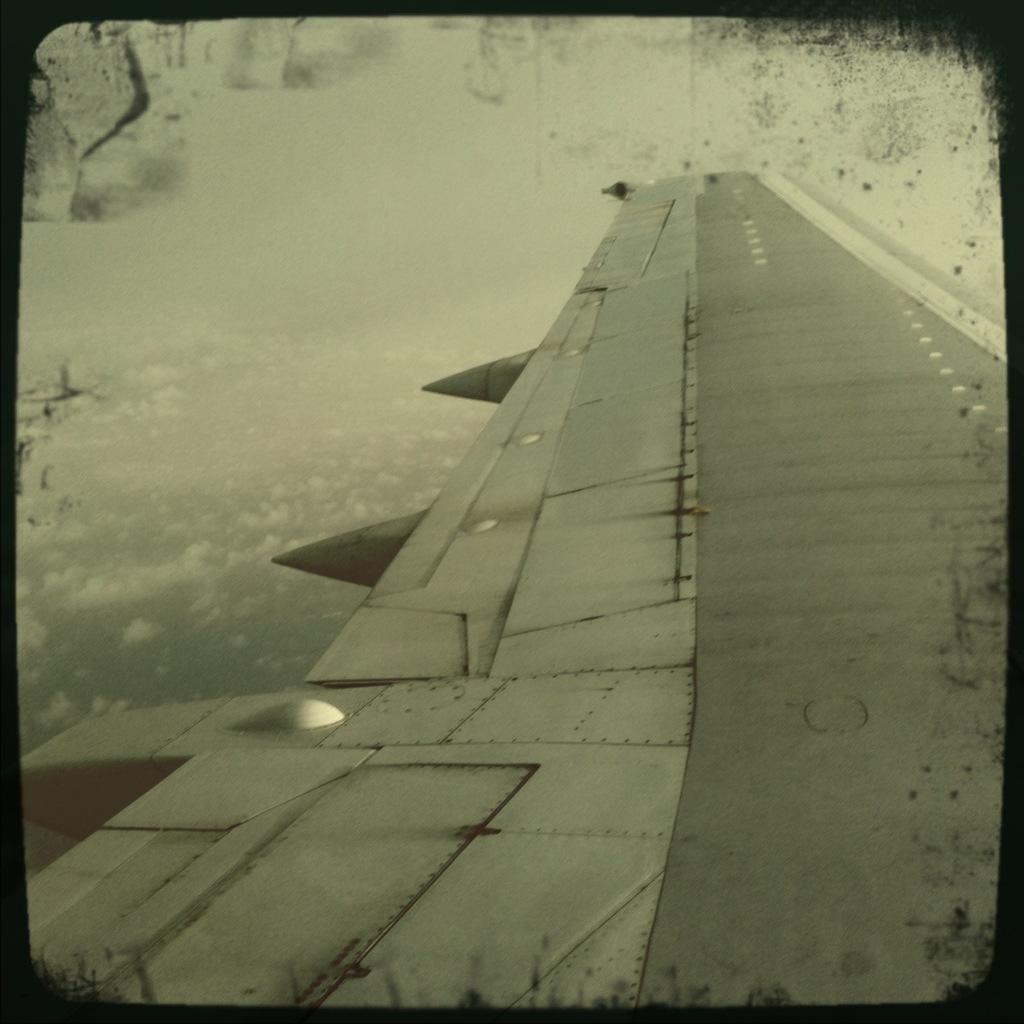Describe this image in one or two sentences. In this picture we can see an airplane wing and this is a black and white picture. 